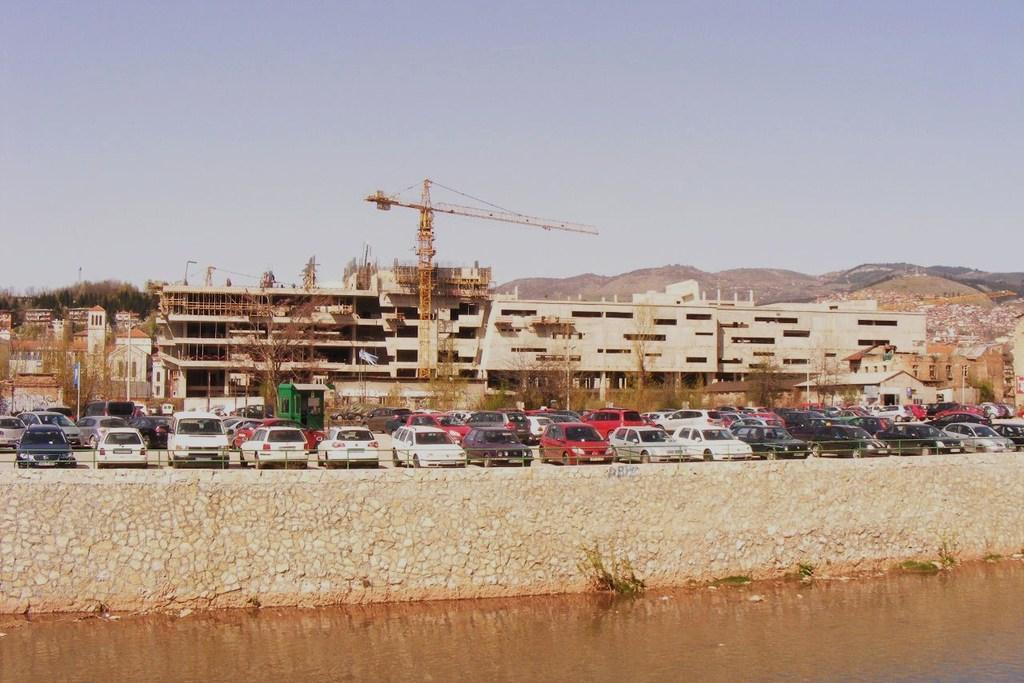Can you describe this image briefly? In this picture there are cars behind the railing and there are buildings, trees and mountains and there is a crane. At the top there is sky. At the bottom there is water and there are plants. 